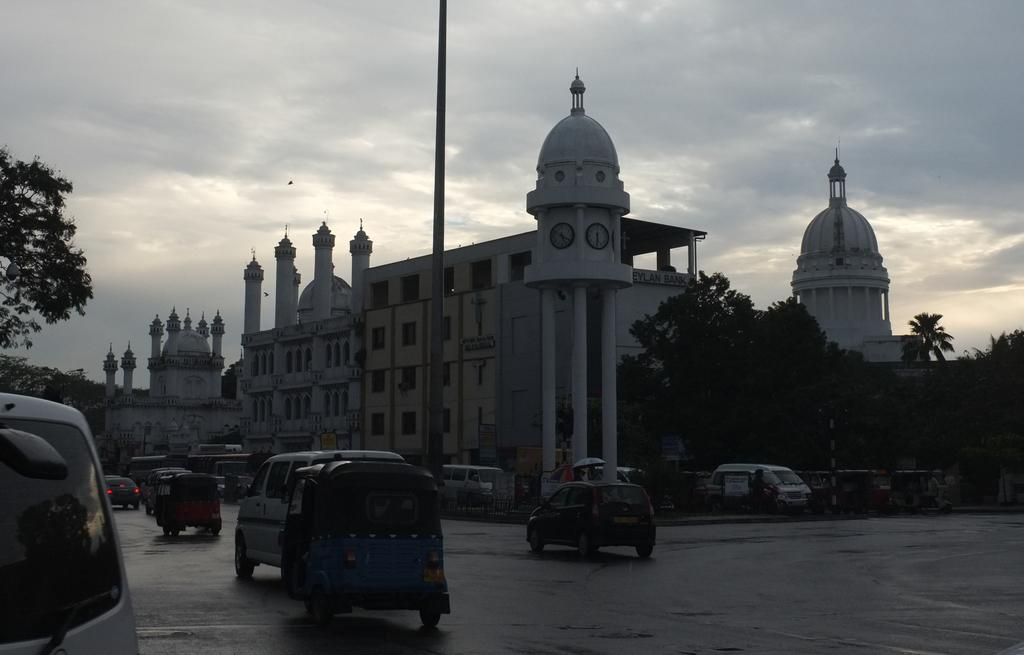What type of structures can be seen in the image? There are buildings in the image. What is happening on the road in the image? Vehicles are moving on the road in the image. What type of vegetation is present beside the road in the image? There are trees beside the road in the image. Where is the sack hanging in the image? There is no sack present in the image. What type of stove is visible in the image? There is no stove present in the image. 